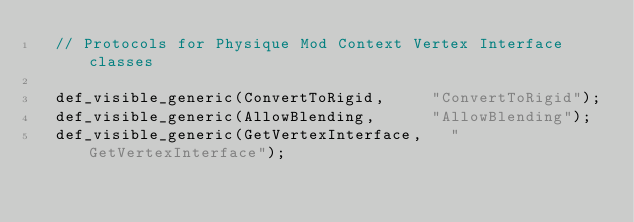Convert code to text. <code><loc_0><loc_0><loc_500><loc_500><_C_>	// Protocols for Physique Mod Context Vertex Interface classes
	
	def_visible_generic(ConvertToRigid,			"ConvertToRigid");
	def_visible_generic(AllowBlending,			"AllowBlending");
	def_visible_generic(GetVertexInterface,		"GetVertexInterface");
</code> 